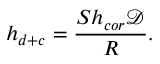<formula> <loc_0><loc_0><loc_500><loc_500>h _ { d + c } = \frac { S h _ { c o r } \mathcal { D } } { R } .</formula> 